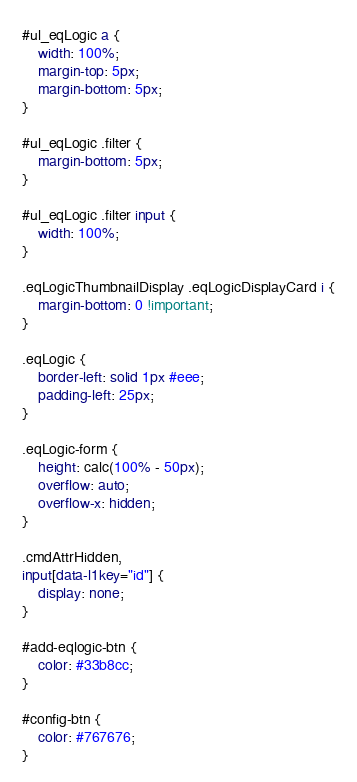Convert code to text. <code><loc_0><loc_0><loc_500><loc_500><_CSS_>#ul_eqLogic a {
    width: 100%;
    margin-top: 5px;
    margin-bottom: 5px;
}

#ul_eqLogic .filter {
    margin-bottom: 5px;
}

#ul_eqLogic .filter input {
    width: 100%;
}

.eqLogicThumbnailDisplay .eqLogicDisplayCard i {
    margin-bottom: 0 !important;
}

.eqLogic {
    border-left: solid 1px #eee;
    padding-left: 25px;
}

.eqLogic-form {
    height: calc(100% - 50px);
    overflow: auto;
    overflow-x: hidden;
}

.cmdAttrHidden,
input[data-l1key="id"] {
    display: none;
}

#add-eqlogic-btn {
    color: #33b8cc;
}

#config-btn {
    color: #767676;
}</code> 